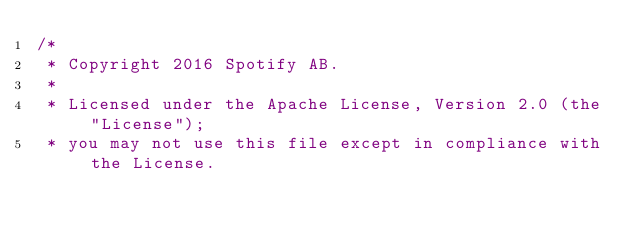<code> <loc_0><loc_0><loc_500><loc_500><_Scala_>/*
 * Copyright 2016 Spotify AB.
 *
 * Licensed under the Apache License, Version 2.0 (the "License");
 * you may not use this file except in compliance with the License.</code> 